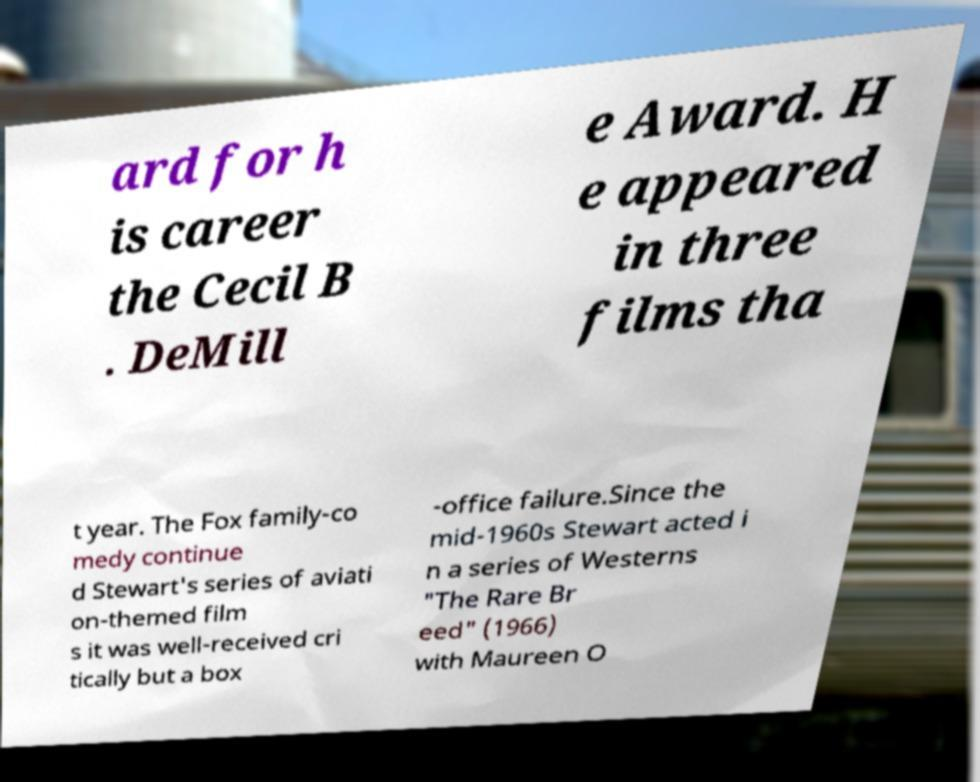Can you read and provide the text displayed in the image?This photo seems to have some interesting text. Can you extract and type it out for me? ard for h is career the Cecil B . DeMill e Award. H e appeared in three films tha t year. The Fox family-co medy continue d Stewart's series of aviati on-themed film s it was well-received cri tically but a box -office failure.Since the mid-1960s Stewart acted i n a series of Westerns "The Rare Br eed" (1966) with Maureen O 